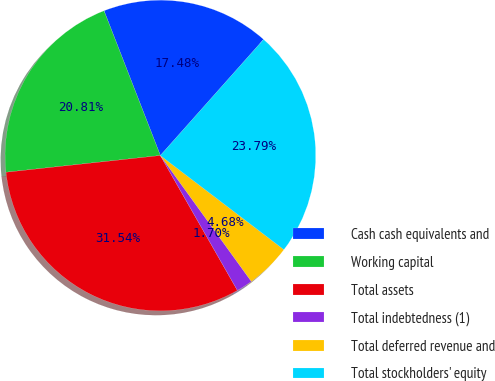Convert chart to OTSL. <chart><loc_0><loc_0><loc_500><loc_500><pie_chart><fcel>Cash cash equivalents and<fcel>Working capital<fcel>Total assets<fcel>Total indebtedness (1)<fcel>Total deferred revenue and<fcel>Total stockholders' equity<nl><fcel>17.48%<fcel>20.81%<fcel>31.54%<fcel>1.7%<fcel>4.68%<fcel>23.79%<nl></chart> 